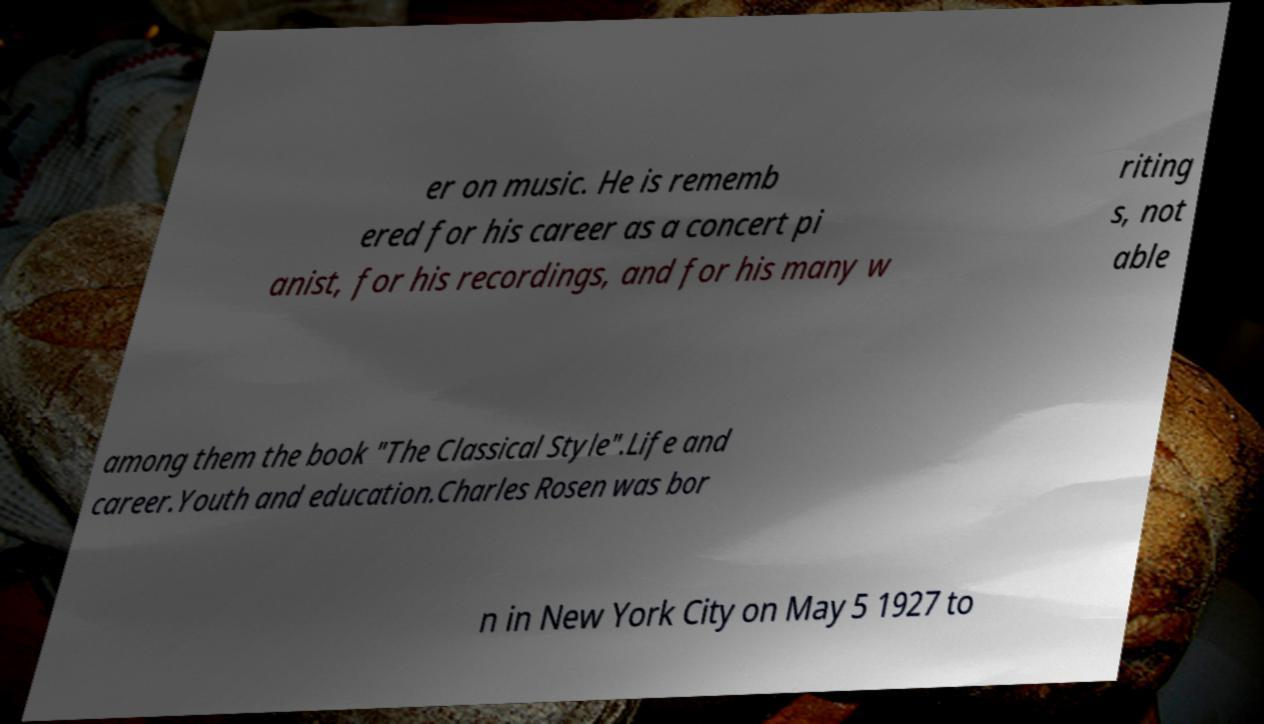Please identify and transcribe the text found in this image. er on music. He is rememb ered for his career as a concert pi anist, for his recordings, and for his many w riting s, not able among them the book "The Classical Style".Life and career.Youth and education.Charles Rosen was bor n in New York City on May 5 1927 to 